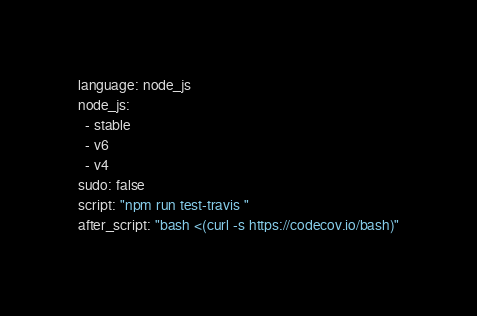<code> <loc_0><loc_0><loc_500><loc_500><_YAML_>language: node_js
node_js:
  - stable
  - v6
  - v4
sudo: false
script: "npm run test-travis "
after_script: "bash <(curl -s https://codecov.io/bash)"
</code> 